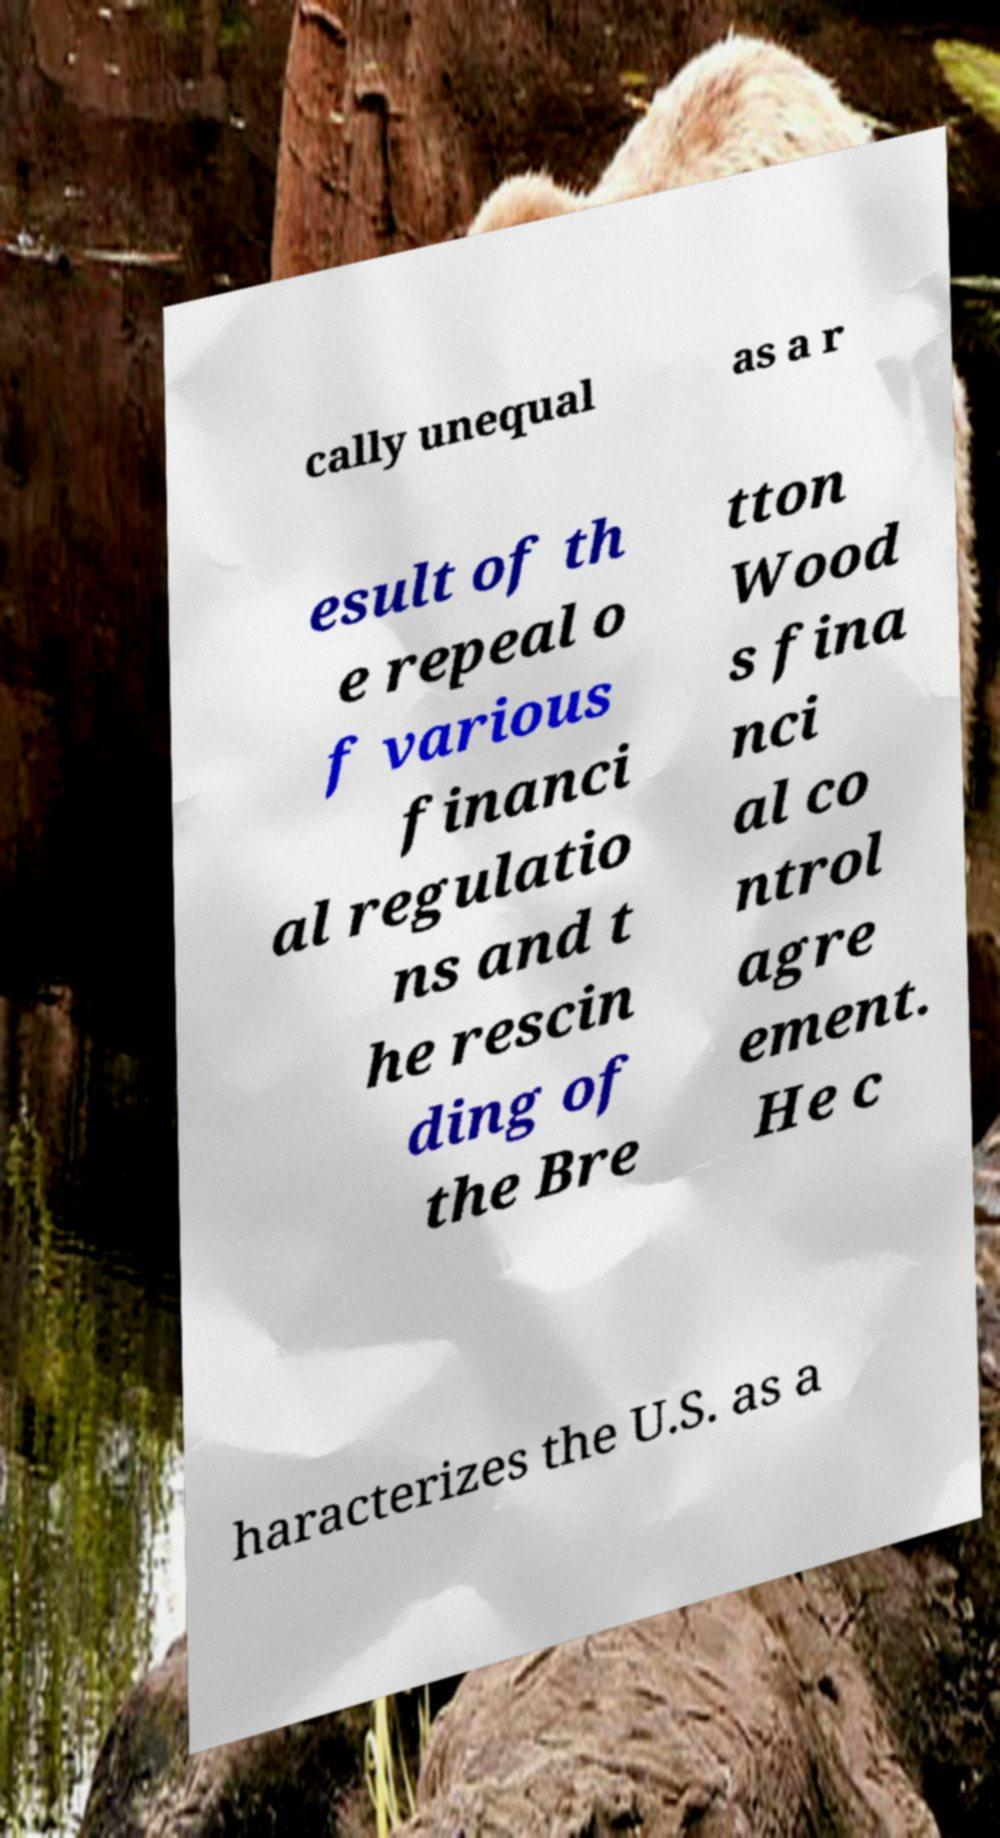For documentation purposes, I need the text within this image transcribed. Could you provide that? cally unequal as a r esult of th e repeal o f various financi al regulatio ns and t he rescin ding of the Bre tton Wood s fina nci al co ntrol agre ement. He c haracterizes the U.S. as a 